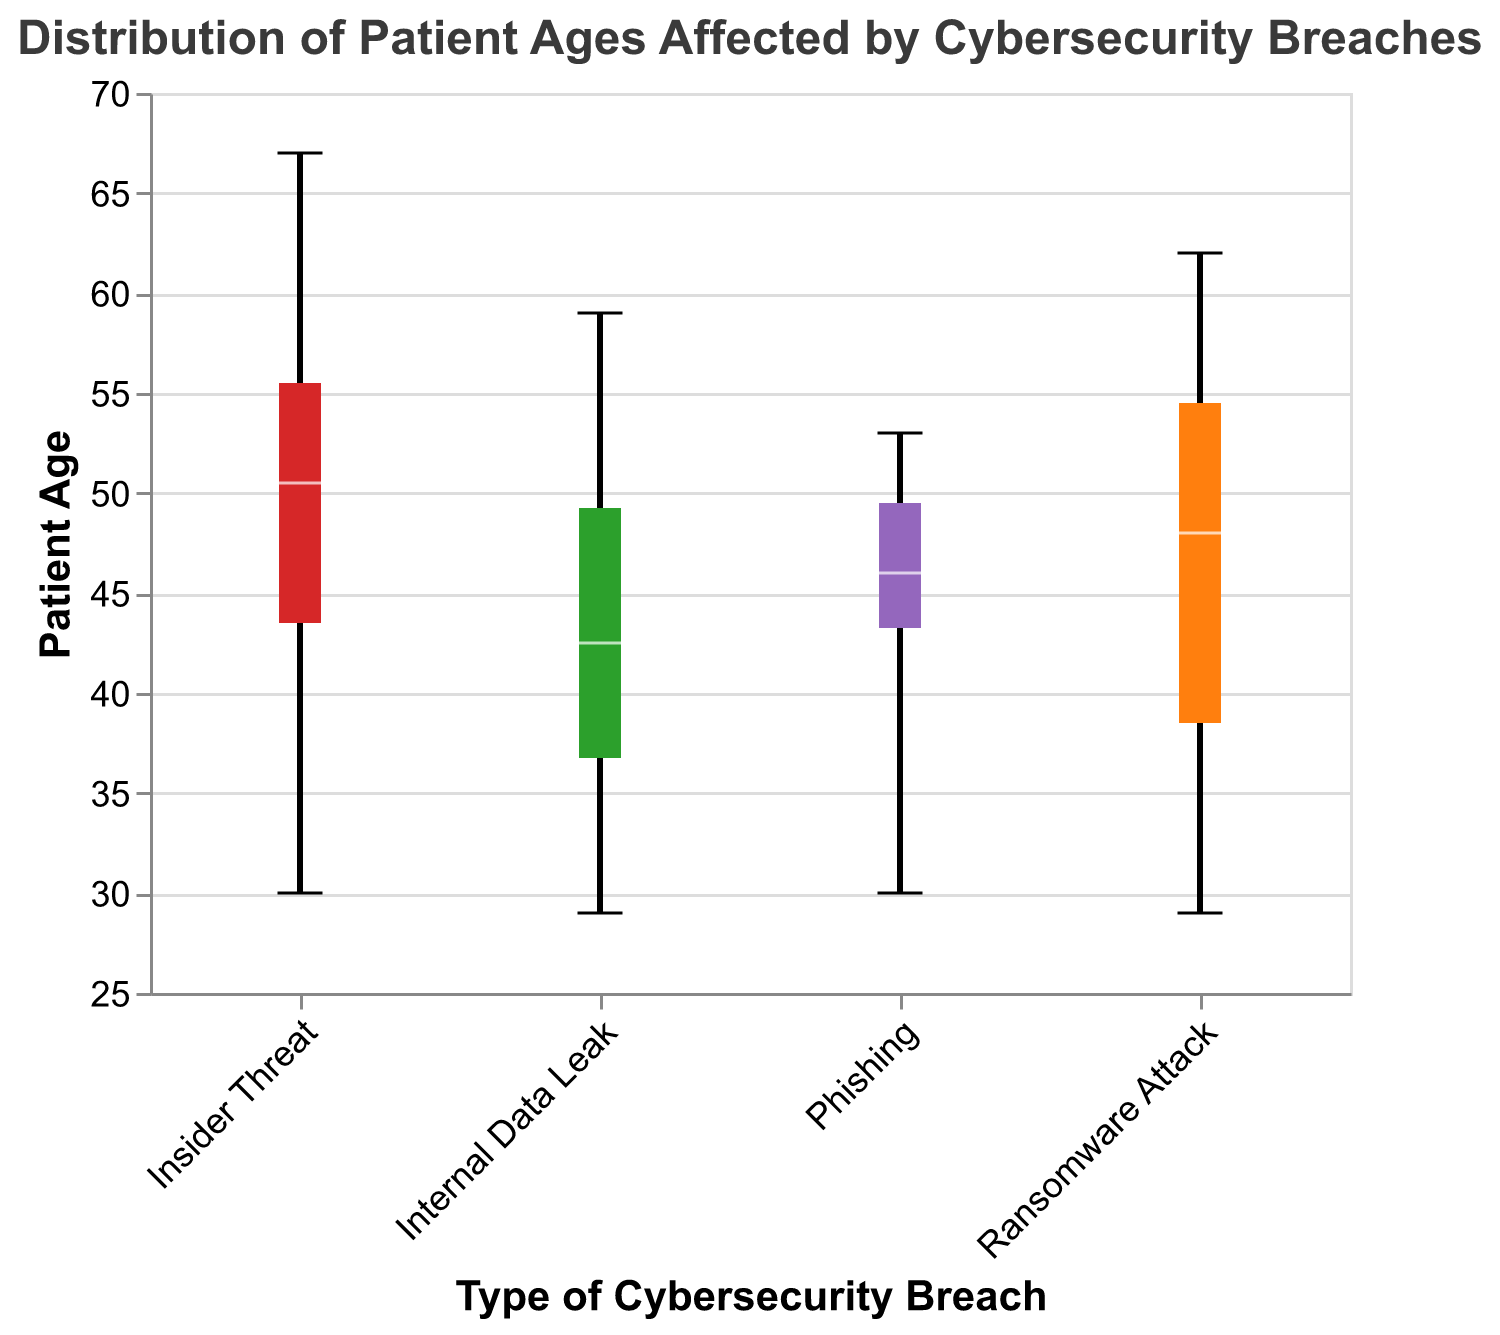What is the title of the figure? The title is displayed at the top of the chart and indicates the content of the chart.
Answer: Distribution of Patient Ages Affected by Cybersecurity Breaches What are the types of cybersecurity breaches represented in the figure? The X-axis lists the different categories of breaches.
Answer: Ransomware Attack, Internal Data Leak, Insider Threat, Phishing Which type of breach has the widest interquartile range (IQR) for patient ages? The interquartile range is the distance between the first and third quartiles in the box plot. Identify which breach shows the largest box length vertically.
Answer: Insider Threat What is the median age of patients affected by phishing attacks? The median is represented by the white line inside the box. Locate the box for Phishing and check the value at the white line.
Answer: 47 Are there any outliers in the ages affected by internal data leaks? Outliers are represented by points outside the whiskers of the box plots. Look at the box for Internal Data Leak and check for any points clearly beyond the whiskers.
Answer: No Which type of breach affects the oldest patient age on record? The maximum age is the top whisker of the box plot. Identify the highest whisker among all breaches.
Answer: Insider Threat Compare the median patient ages of ransomware attacks and insider threats. Which is higher? Locate the median (white line) for each breach and compare the values.
Answer: Insider Threat What is the range of ages for patients affected by ransomware attacks? The range is calculated by subtracting the smallest value (bottom whisker) from the largest value (top whisker) for Ransomware Attack.
Answer: 33 (62 - 29) How does the median age for phishing attacks compare to the median age for internal data leaks? Compare the medians (white lines) for Phishing and Internal Data Leak.
Answer: Nearly the same 